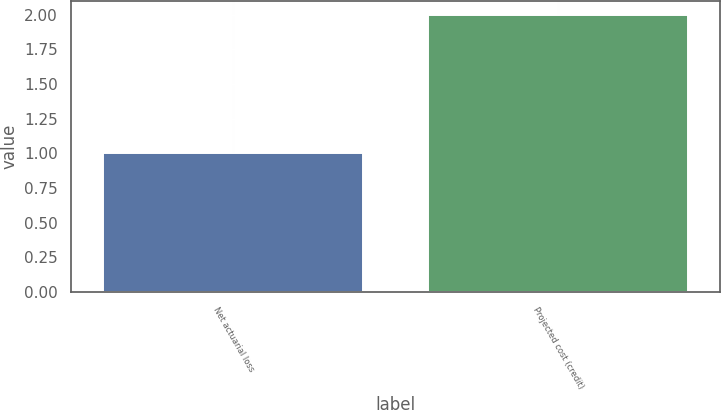Convert chart. <chart><loc_0><loc_0><loc_500><loc_500><bar_chart><fcel>Net actuarial loss<fcel>Projected cost (credit)<nl><fcel>1<fcel>2<nl></chart> 